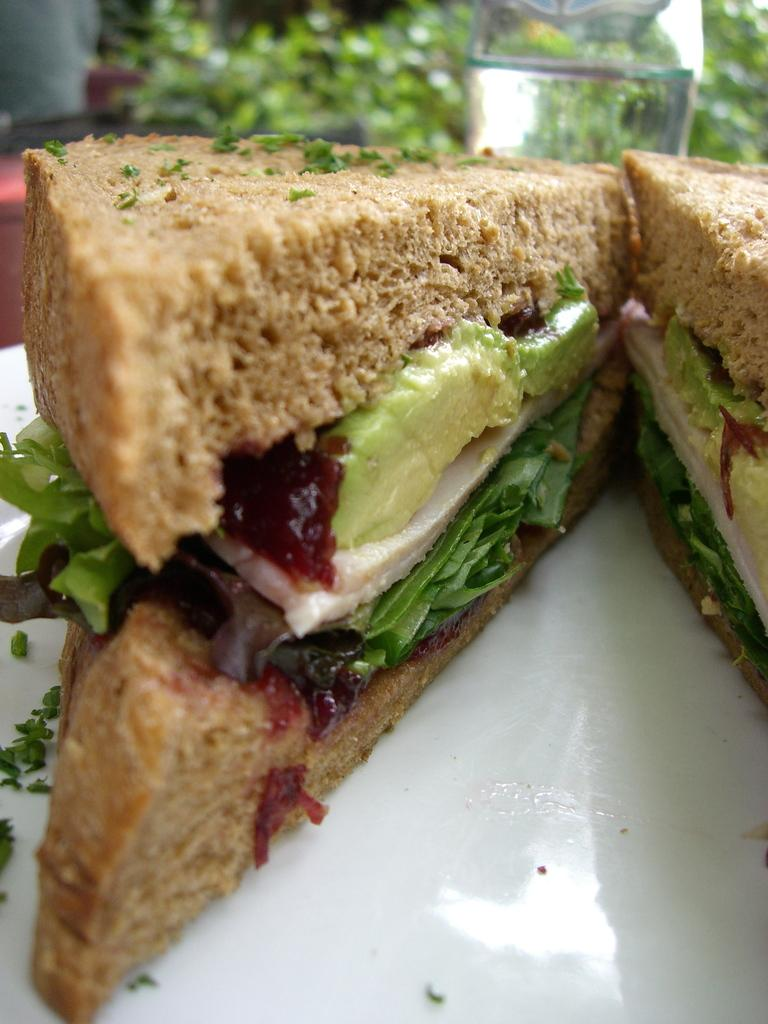What type of food is on the plate in the image? There are bread sandwiches on a white plate in the image. What can be seen in the background of the image? There is a jar with water and plants in the background. How would you describe the overall clarity of the image? The image appears blurry. What type of drink is being served at the event in the image? There is no event or drink present in the image; it only shows bread sandwiches on a plate, a jar with water, and plants in the background. Can you see a hen in the image? There is no hen present in the image. 